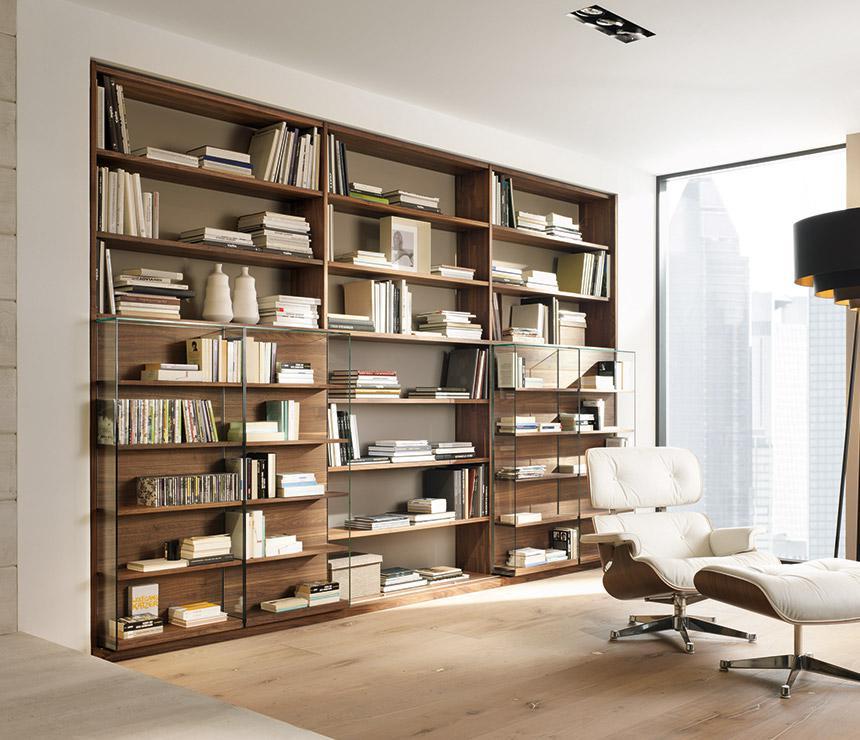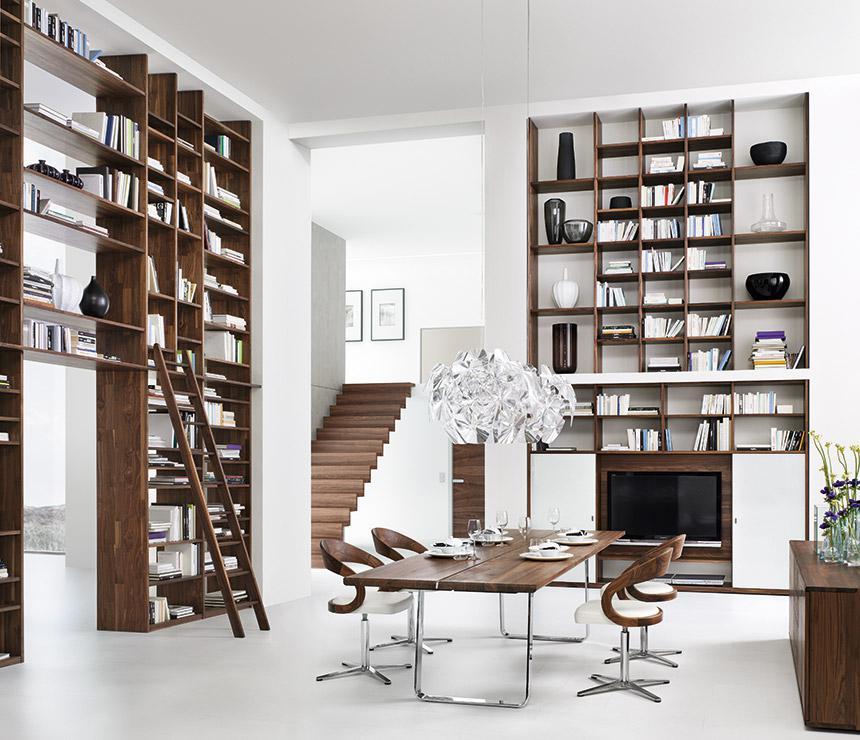The first image is the image on the left, the second image is the image on the right. Considering the images on both sides, is "The left image shows an all white bookcase with an open back." valid? Answer yes or no. No. 